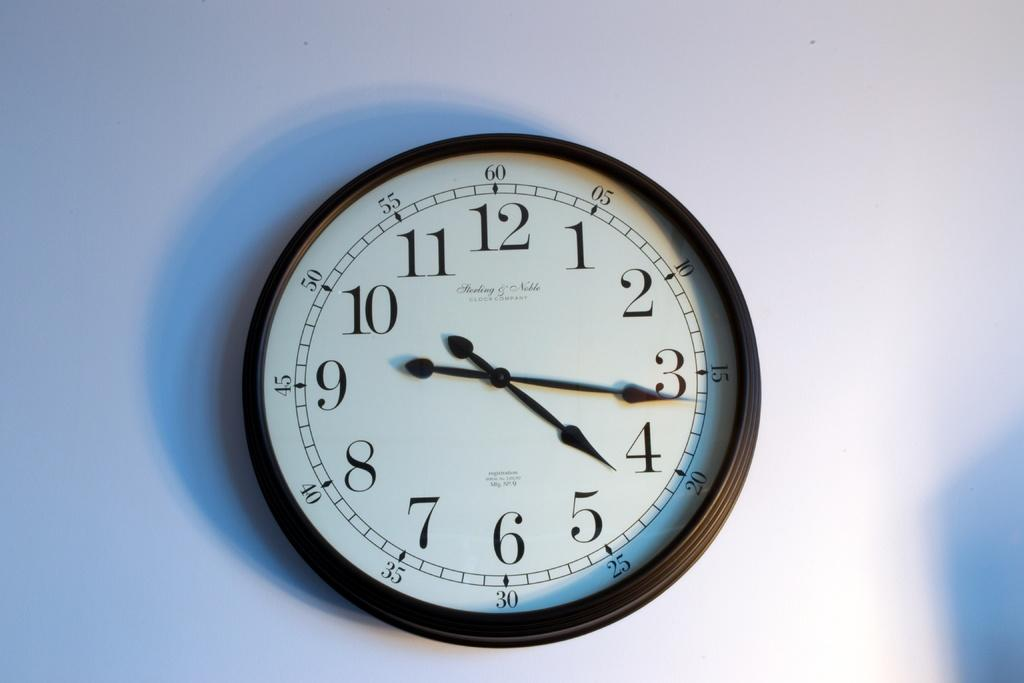Provide a one-sentence caption for the provided image. a clock mounted on the wall with the time if 4:16. 